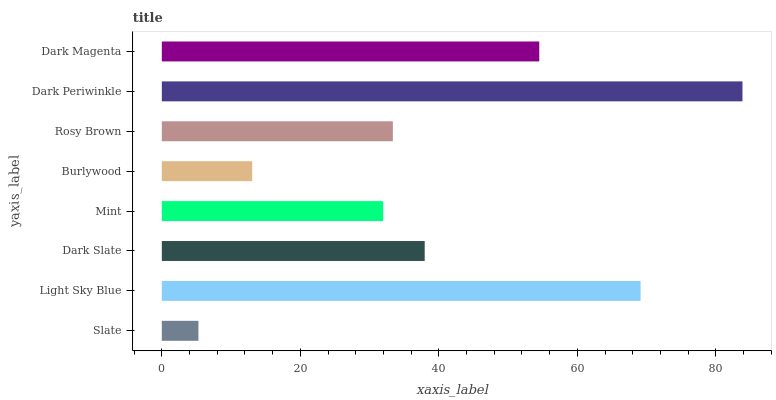Is Slate the minimum?
Answer yes or no. Yes. Is Dark Periwinkle the maximum?
Answer yes or no. Yes. Is Light Sky Blue the minimum?
Answer yes or no. No. Is Light Sky Blue the maximum?
Answer yes or no. No. Is Light Sky Blue greater than Slate?
Answer yes or no. Yes. Is Slate less than Light Sky Blue?
Answer yes or no. Yes. Is Slate greater than Light Sky Blue?
Answer yes or no. No. Is Light Sky Blue less than Slate?
Answer yes or no. No. Is Dark Slate the high median?
Answer yes or no. Yes. Is Rosy Brown the low median?
Answer yes or no. Yes. Is Rosy Brown the high median?
Answer yes or no. No. Is Dark Magenta the low median?
Answer yes or no. No. 